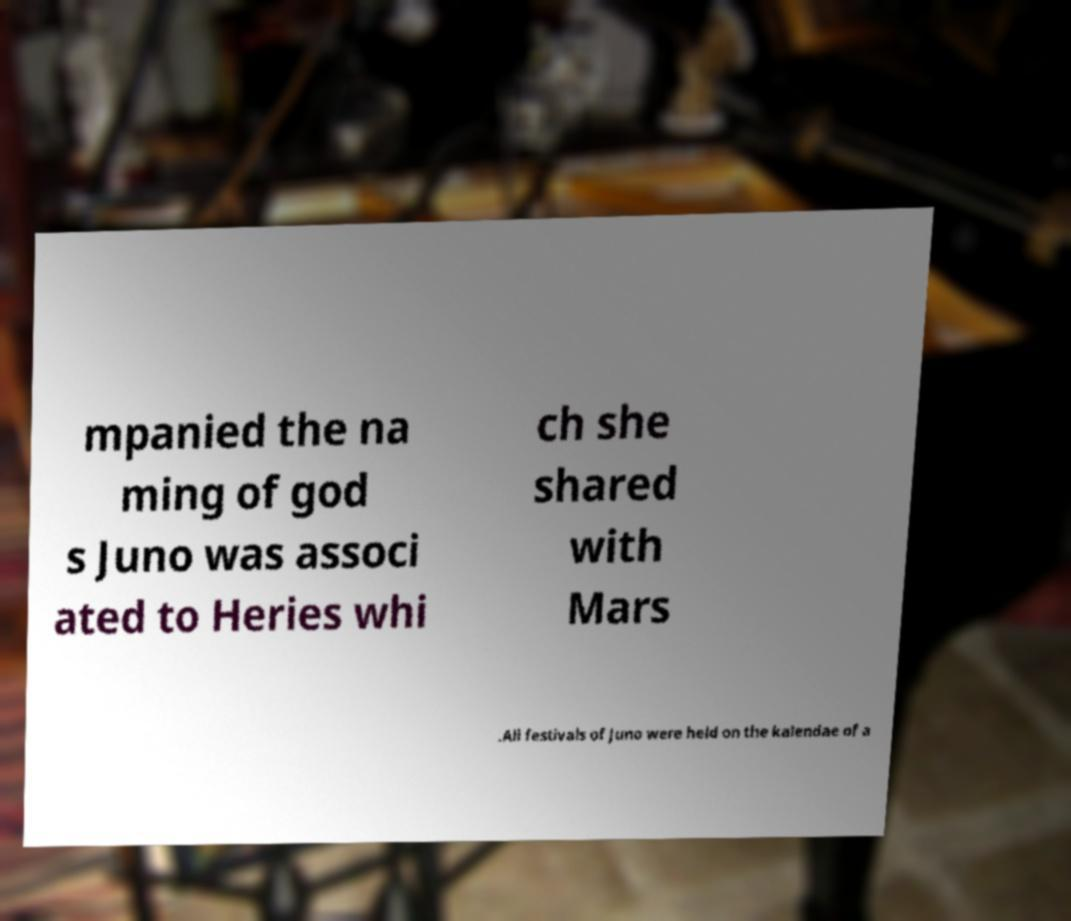What messages or text are displayed in this image? I need them in a readable, typed format. mpanied the na ming of god s Juno was associ ated to Heries whi ch she shared with Mars .All festivals of Juno were held on the kalendae of a 